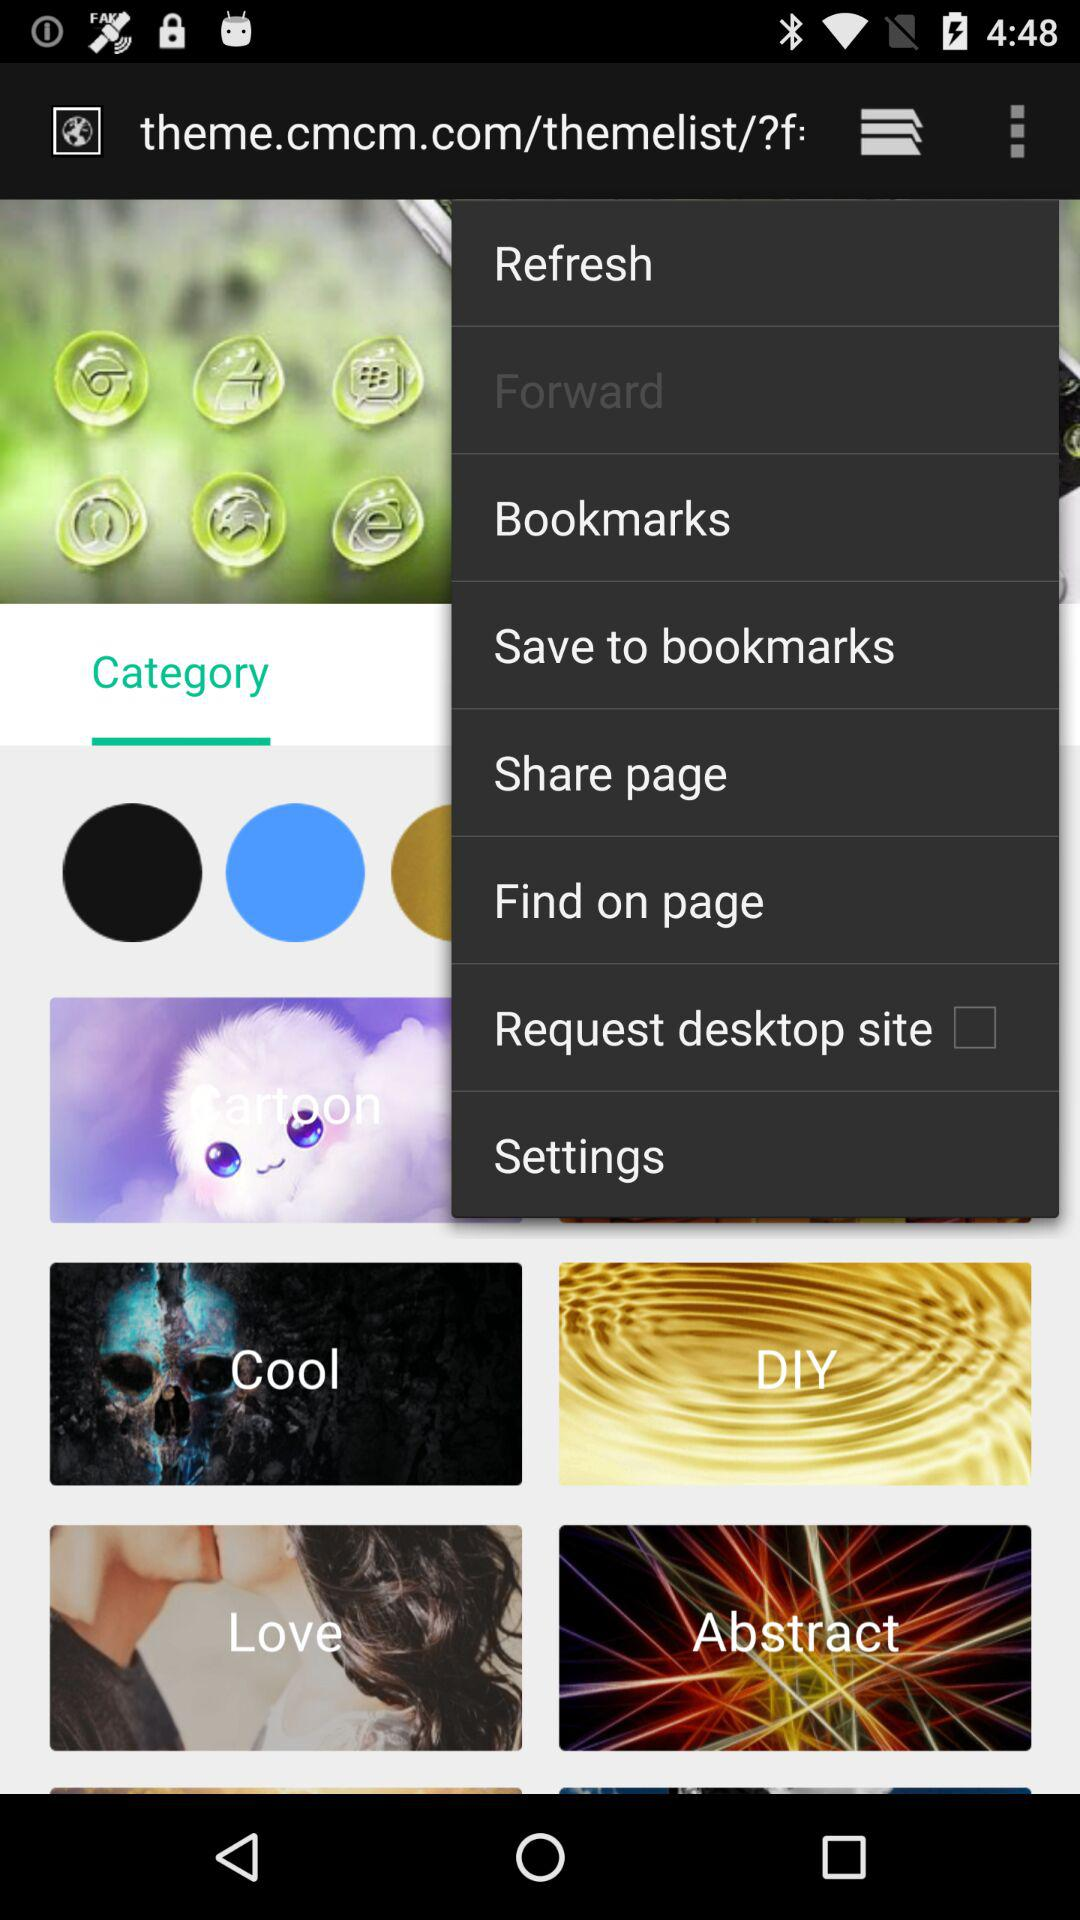Is "Request desktop site" checked or unchecked? The "Request desktop site" is unchecked. 